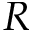Convert formula to latex. <formula><loc_0><loc_0><loc_500><loc_500>R</formula> 